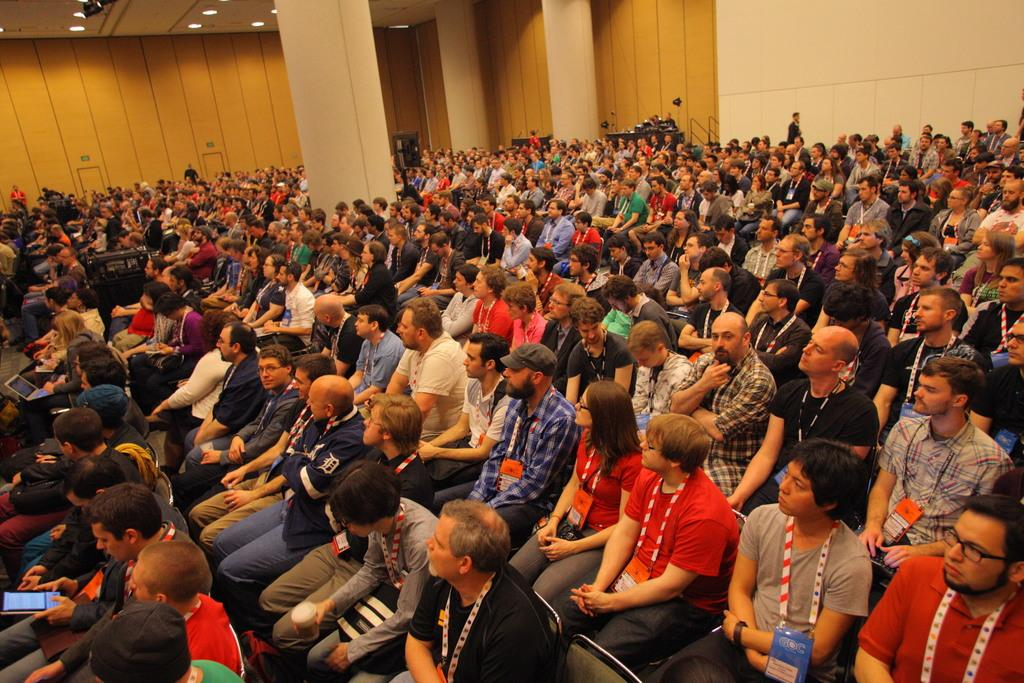What are the people in the image doing? The people in the image are sitting on chairs. What can be seen in the middle of the image? There is a pillar in the middle of the image. What is visible in the background of the image? There is a wall in the background of the image. What is visible at the top of the image? There is a ceiling visible at the top of the image. What might be used for illumination in the image? There are lights present in the image. What is the birth date of the person holding the rifle in the image? There is no person holding a rifle in the image, and therefore no birth date can be determined. 